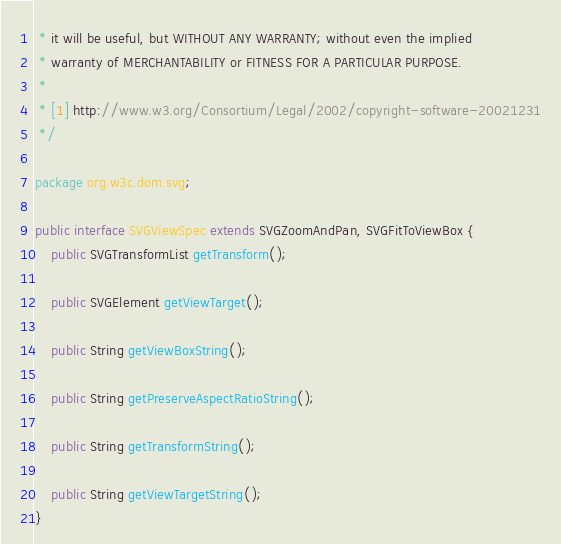<code> <loc_0><loc_0><loc_500><loc_500><_Java_> * it will be useful, but WITHOUT ANY WARRANTY; without even the implied
 * warranty of MERCHANTABILITY or FITNESS FOR A PARTICULAR PURPOSE.
 *
 * [1] http://www.w3.org/Consortium/Legal/2002/copyright-software-20021231
 */

package org.w3c.dom.svg;

public interface SVGViewSpec extends SVGZoomAndPan, SVGFitToViewBox {
	public SVGTransformList getTransform();

	public SVGElement getViewTarget();

	public String getViewBoxString();

	public String getPreserveAspectRatioString();

	public String getTransformString();

	public String getViewTargetString();
}
</code> 